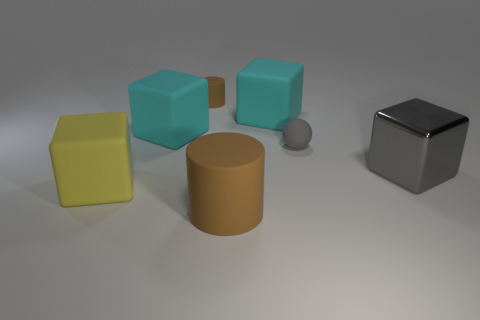Add 3 small yellow rubber cylinders. How many objects exist? 10 Subtract all big yellow cubes. How many cubes are left? 3 Subtract all brown blocks. Subtract all yellow spheres. How many blocks are left? 4 Subtract all red cylinders. How many cyan blocks are left? 2 Subtract all large gray blocks. Subtract all gray things. How many objects are left? 4 Add 4 big matte cylinders. How many big matte cylinders are left? 5 Add 4 tiny brown matte things. How many tiny brown matte things exist? 5 Subtract all cyan blocks. How many blocks are left? 2 Subtract 0 red cubes. How many objects are left? 7 Subtract all spheres. How many objects are left? 6 